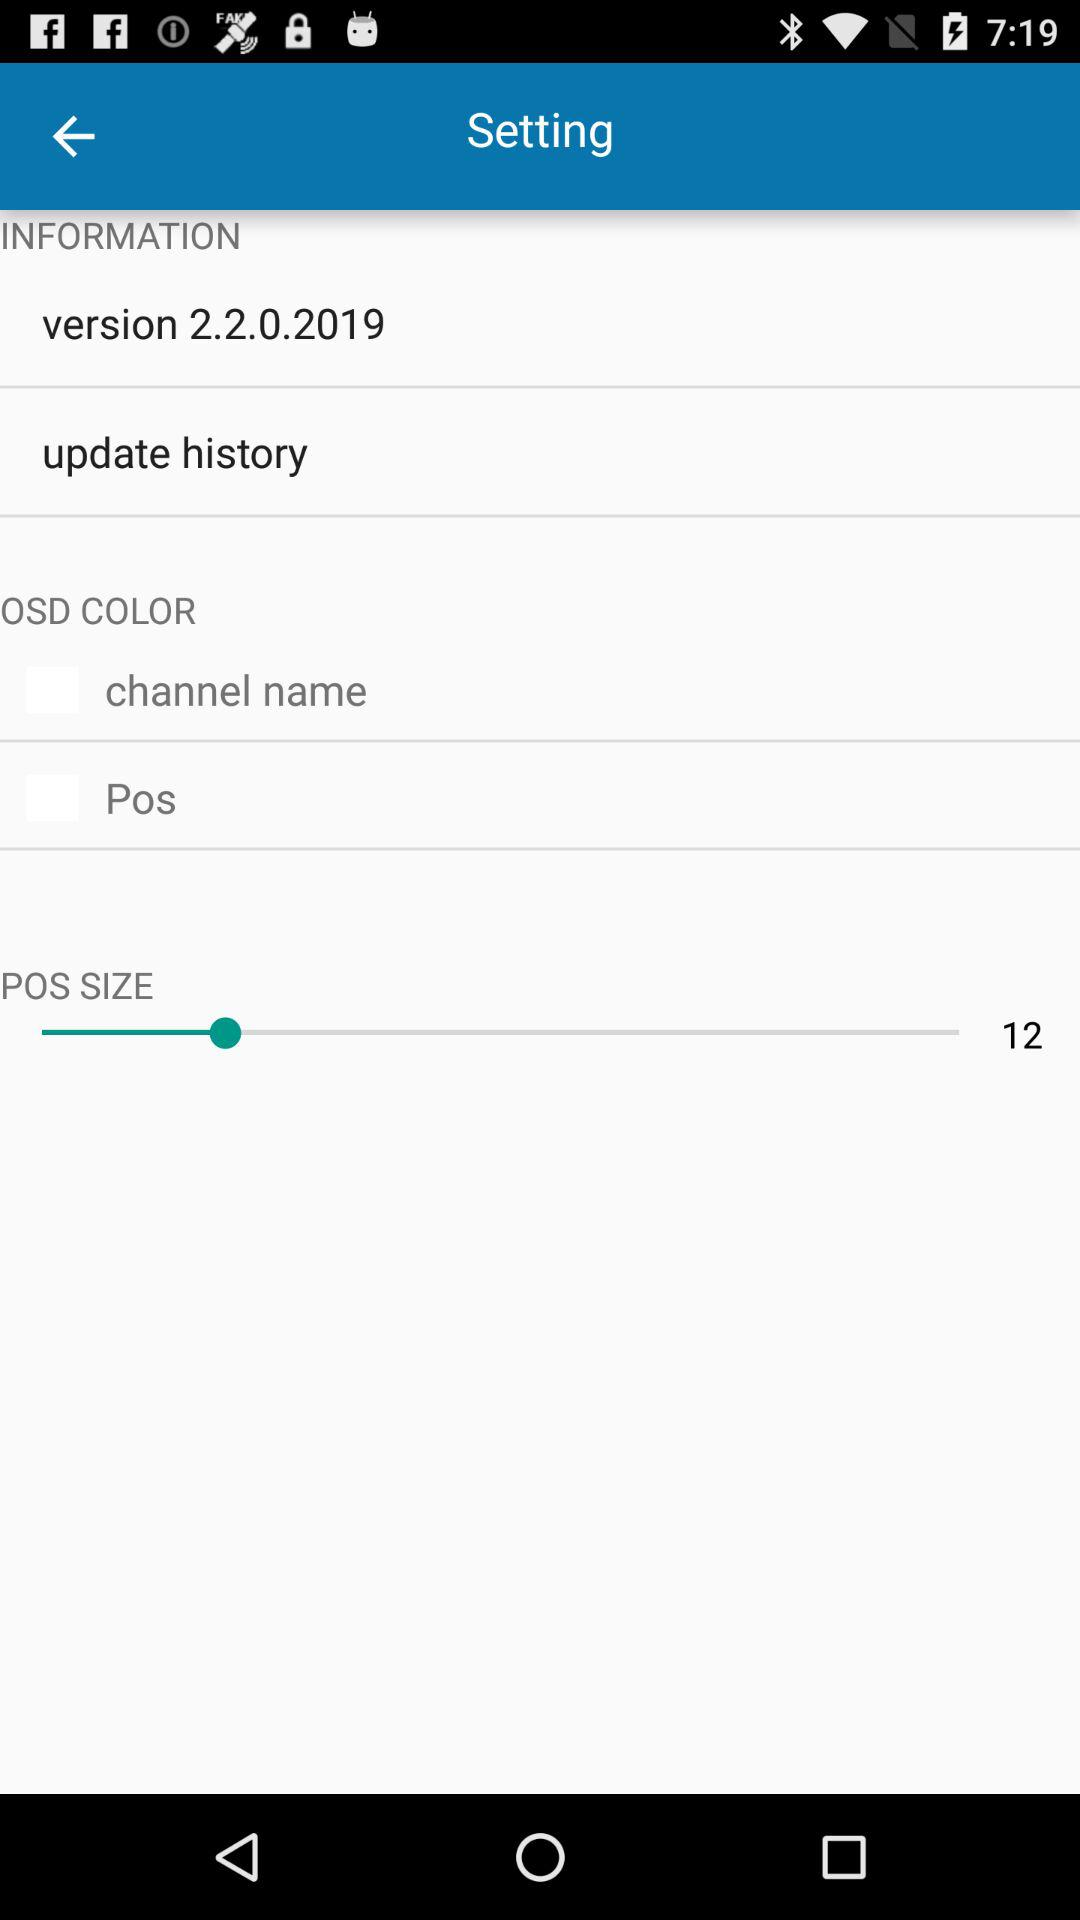What is the given channel name? The given channel name is "Pos". 